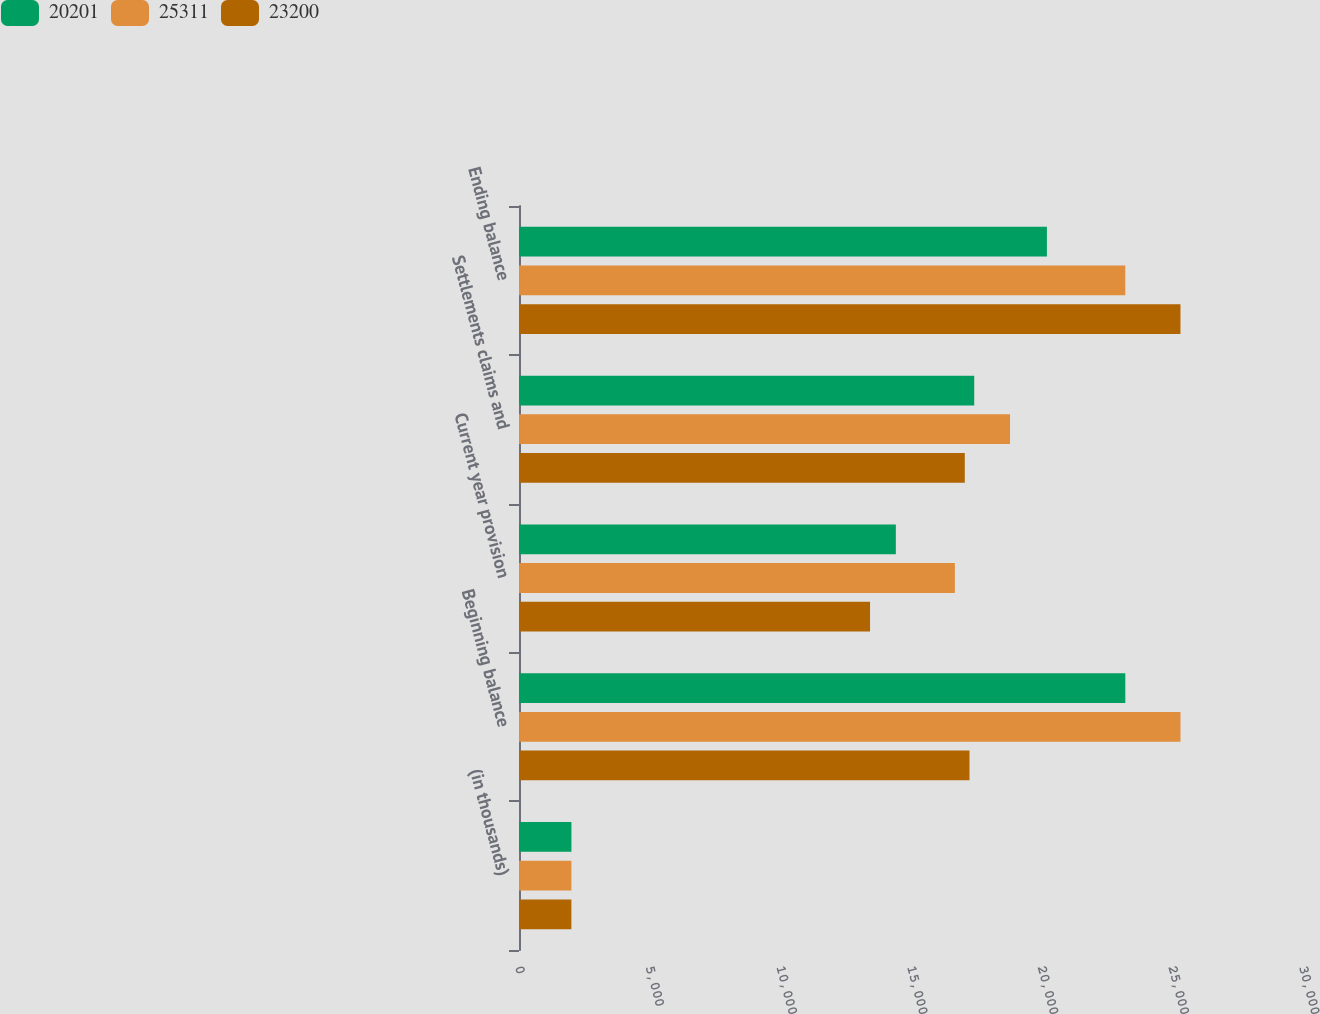<chart> <loc_0><loc_0><loc_500><loc_500><stacked_bar_chart><ecel><fcel>(in thousands)<fcel>Beginning balance<fcel>Current year provision<fcel>Settlements claims and<fcel>Ending balance<nl><fcel>20201<fcel>2006<fcel>23200<fcel>14420<fcel>17419<fcel>20201<nl><fcel>25311<fcel>2005<fcel>25311<fcel>16679<fcel>18790<fcel>23200<nl><fcel>23200<fcel>2004<fcel>17238.5<fcel>13433<fcel>17058<fcel>25311<nl></chart> 